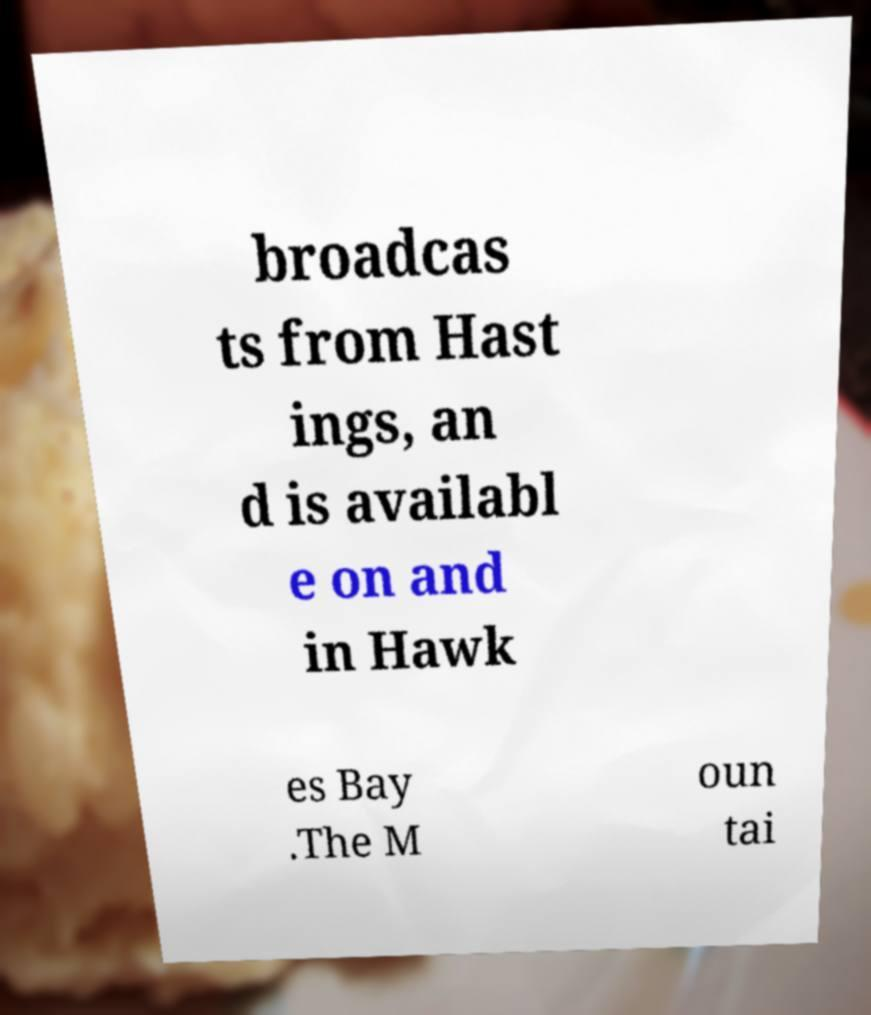There's text embedded in this image that I need extracted. Can you transcribe it verbatim? broadcas ts from Hast ings, an d is availabl e on and in Hawk es Bay .The M oun tai 